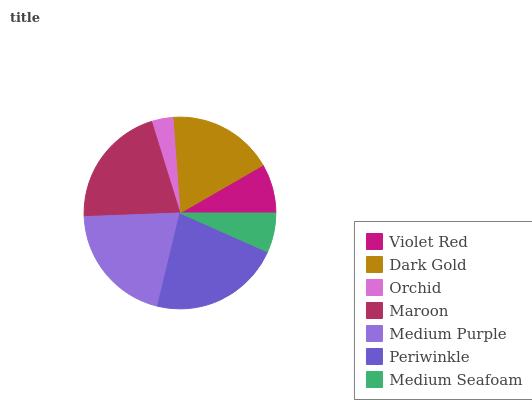Is Orchid the minimum?
Answer yes or no. Yes. Is Periwinkle the maximum?
Answer yes or no. Yes. Is Dark Gold the minimum?
Answer yes or no. No. Is Dark Gold the maximum?
Answer yes or no. No. Is Dark Gold greater than Violet Red?
Answer yes or no. Yes. Is Violet Red less than Dark Gold?
Answer yes or no. Yes. Is Violet Red greater than Dark Gold?
Answer yes or no. No. Is Dark Gold less than Violet Red?
Answer yes or no. No. Is Dark Gold the high median?
Answer yes or no. Yes. Is Dark Gold the low median?
Answer yes or no. Yes. Is Violet Red the high median?
Answer yes or no. No. Is Medium Seafoam the low median?
Answer yes or no. No. 